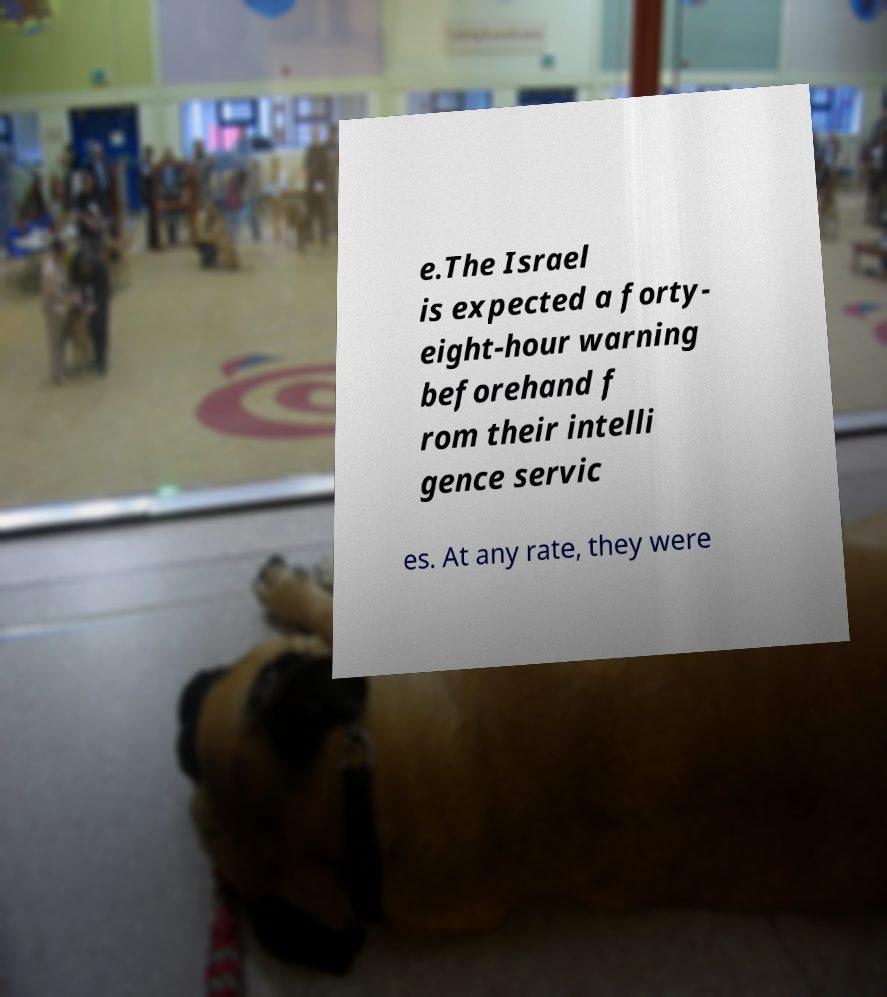There's text embedded in this image that I need extracted. Can you transcribe it verbatim? e.The Israel is expected a forty- eight-hour warning beforehand f rom their intelli gence servic es. At any rate, they were 